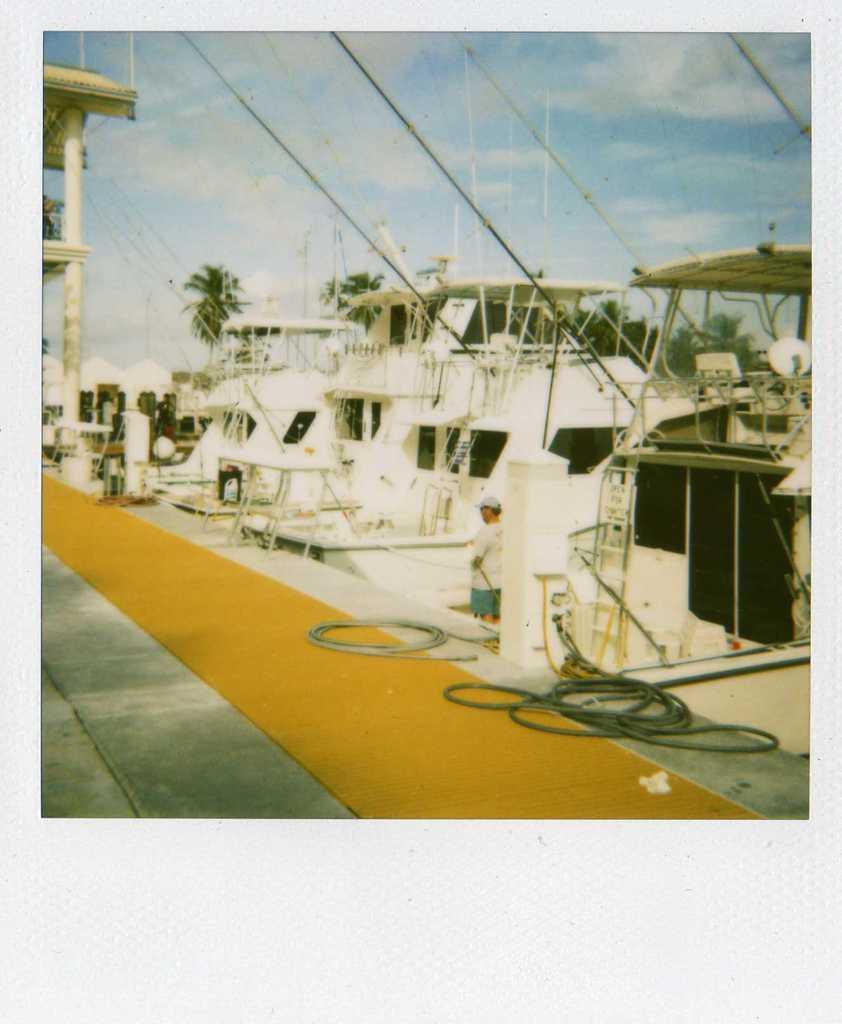Could you give a brief overview of what you see in this image? At the bottom of the image there is a floor with carpet and ropes. And also there are pillars and roof. Behind the floor there are many ships with ropes, poles, glass windows, and some other things. In the background there are trees and also there is sky. 